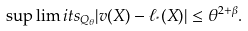Convert formula to latex. <formula><loc_0><loc_0><loc_500><loc_500>\sup \lim i t s _ { Q _ { \theta } } | v ( X ) - \ell _ { ^ { * } } ( X ) | \leq \theta ^ { 2 + \beta } .</formula> 